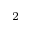<formula> <loc_0><loc_0><loc_500><loc_500>^ { 2 }</formula> 